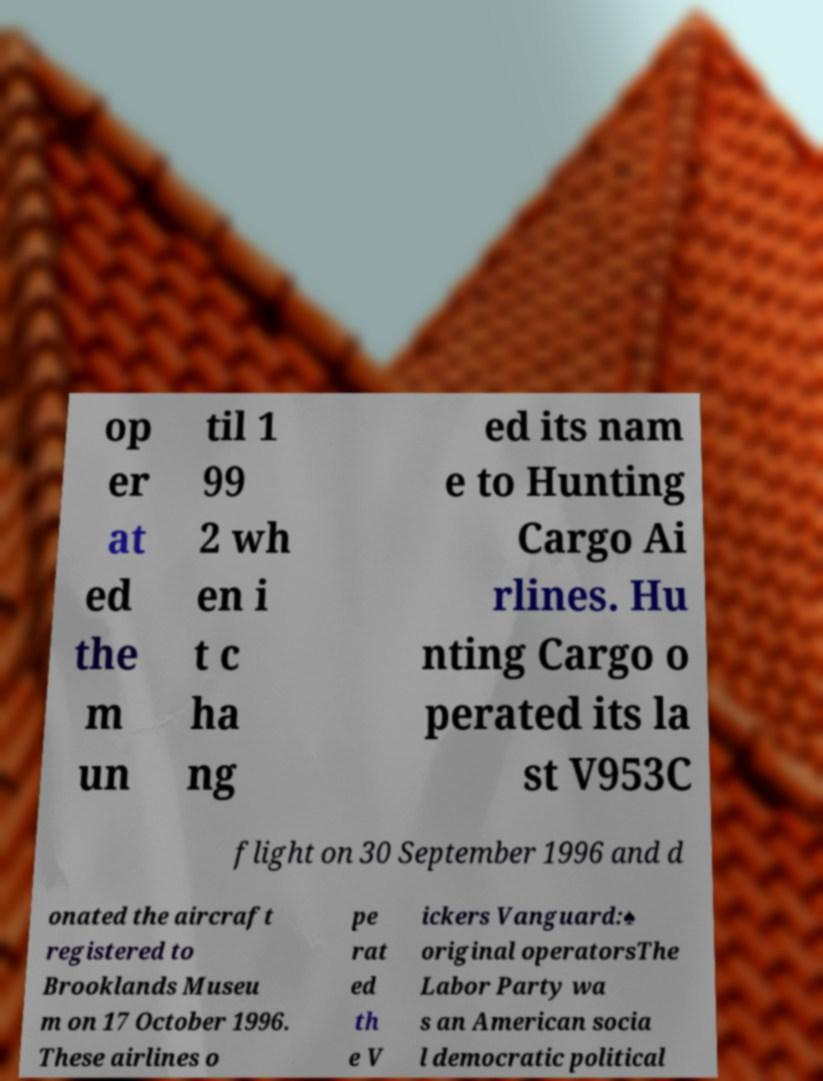Please identify and transcribe the text found in this image. op er at ed the m un til 1 99 2 wh en i t c ha ng ed its nam e to Hunting Cargo Ai rlines. Hu nting Cargo o perated its la st V953C flight on 30 September 1996 and d onated the aircraft registered to Brooklands Museu m on 17 October 1996. These airlines o pe rat ed th e V ickers Vanguard:♠ original operatorsThe Labor Party wa s an American socia l democratic political 